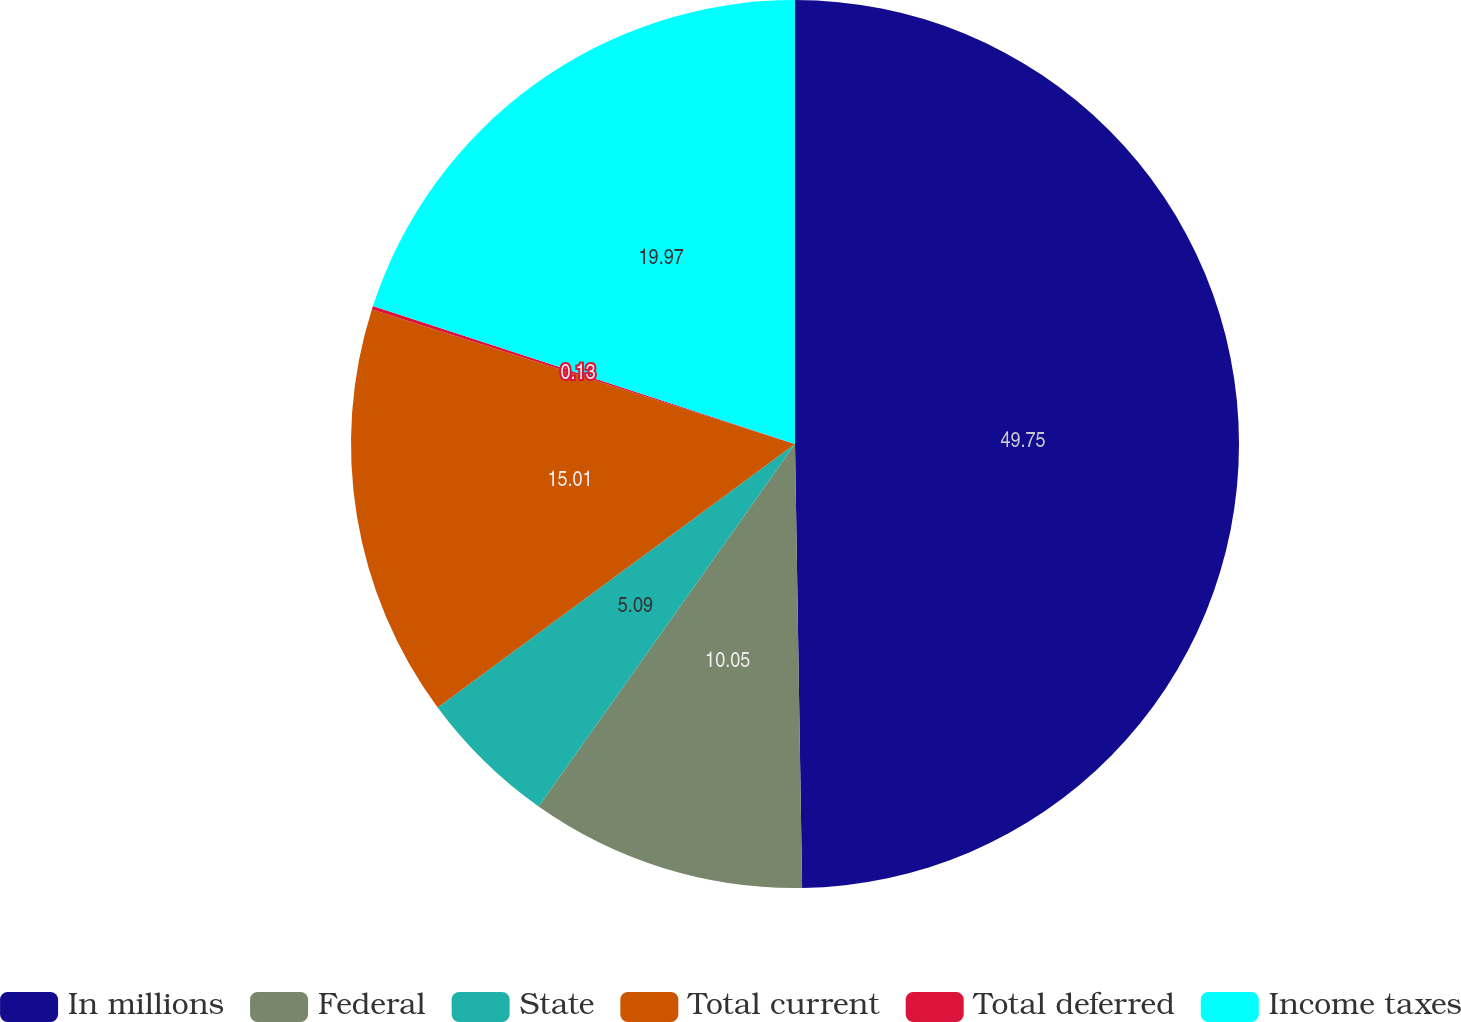<chart> <loc_0><loc_0><loc_500><loc_500><pie_chart><fcel>In millions<fcel>Federal<fcel>State<fcel>Total current<fcel>Total deferred<fcel>Income taxes<nl><fcel>49.74%<fcel>10.05%<fcel>5.09%<fcel>15.01%<fcel>0.13%<fcel>19.97%<nl></chart> 